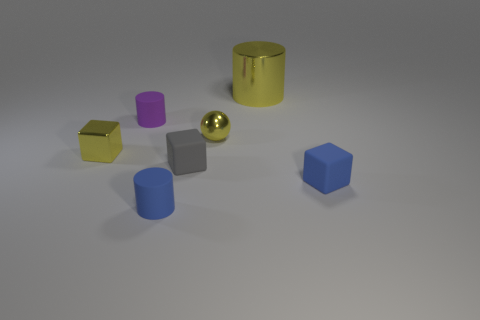Subtract 1 cubes. How many cubes are left? 2 Add 3 yellow balls. How many objects exist? 10 Subtract all yellow cylinders. Subtract all blue spheres. How many cylinders are left? 2 Subtract all cylinders. How many objects are left? 4 Subtract all small gray matte objects. Subtract all big cylinders. How many objects are left? 5 Add 5 yellow cylinders. How many yellow cylinders are left? 6 Add 7 big yellow metal cylinders. How many big yellow metal cylinders exist? 8 Subtract 0 red spheres. How many objects are left? 7 